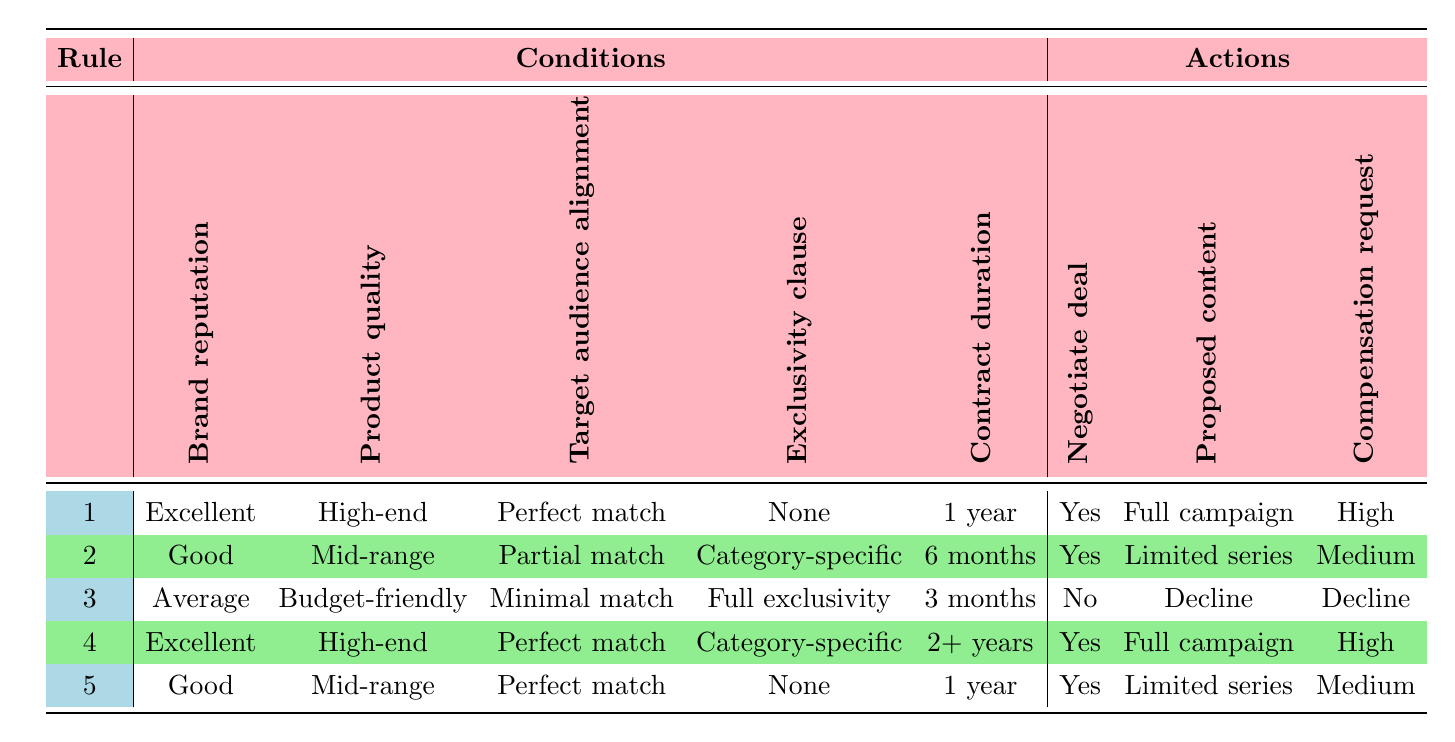What is the brand reputation for the product with a full campaign proposed content under a 1-year contract duration? By checking the table, the only row with "Full campaign" proposed content under a "1 year" contract duration is the first row. The brand reputation in that row is "Excellent."
Answer: Excellent How many rules include a "Good" brand reputation? Looking through the table, there are two rules with "Good" brand reputation: the second and fifth rows. Therefore, the count is 2.
Answer: 2 Is it true that all products with a "High-end" quality have a "Perfect match" for the target audience? Examining the table, it is clear that both rules with "High-end" products have "Perfect match" for target audience alignment. The first and fourth rows support this statement. So, it is true.
Answer: Yes What compensation request is associated with a brand that has "Average" reputation and "Budget-friendly" product quality? From the table, the only rule with "Average" reputation and "Budget-friendly" product quality is the third row, which states a "Decline" for the compensation request.
Answer: Decline Determine the minimum contract duration stated in the table. Analyzing the contract duration options in the table, the minimum value listed is "3 months," which appears in the third row.
Answer: 3 months How many rows propose a "Limited series" as proposed content? The table shows that there are two rows where "Limited series" is proposed as content: the second and fifth rows. Thus, the count is 2.
Answer: 2 If a brand has "Good" reputation and offers a "Category-specific" exclusivity clause, is it always possible to negotiate a deal? Referring to the table, the second row has a "Good" reputation, and it indicates "Yes" for negotiating a deal. However, the rules do not imply that it's always possible, as each case is unique. Therefore, this statement is false.
Answer: No Which proposed content is commonly associated with products that have "Excellent" brand reputation? The table indicates that both rows with "Excellent" brand reputation propose "Full campaign" as the proposed content, specifically in the first and fourth rows.
Answer: Full campaign 